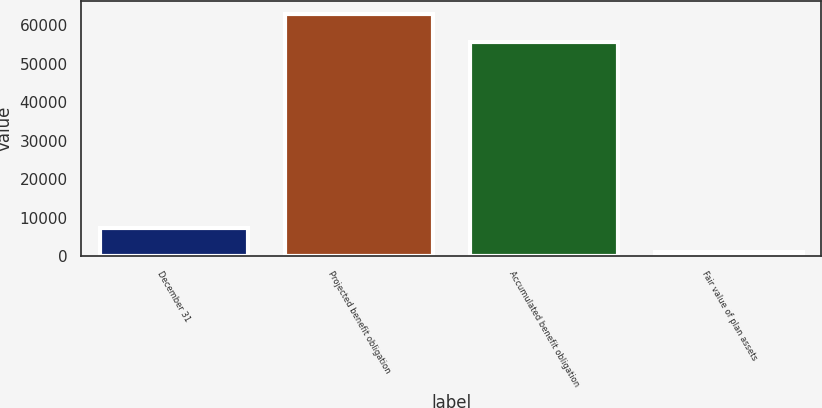Convert chart to OTSL. <chart><loc_0><loc_0><loc_500><loc_500><bar_chart><fcel>December 31<fcel>Projected benefit obligation<fcel>Accumulated benefit obligation<fcel>Fair value of plan assets<nl><fcel>7180.7<fcel>63014<fcel>55623<fcel>977<nl></chart> 